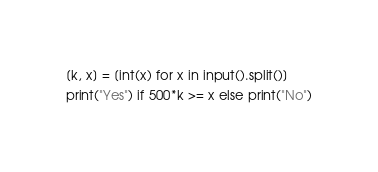Convert code to text. <code><loc_0><loc_0><loc_500><loc_500><_Python_>[k, x] = [int(x) for x in input().split()]
print("Yes") if 500*k >= x else print("No")</code> 